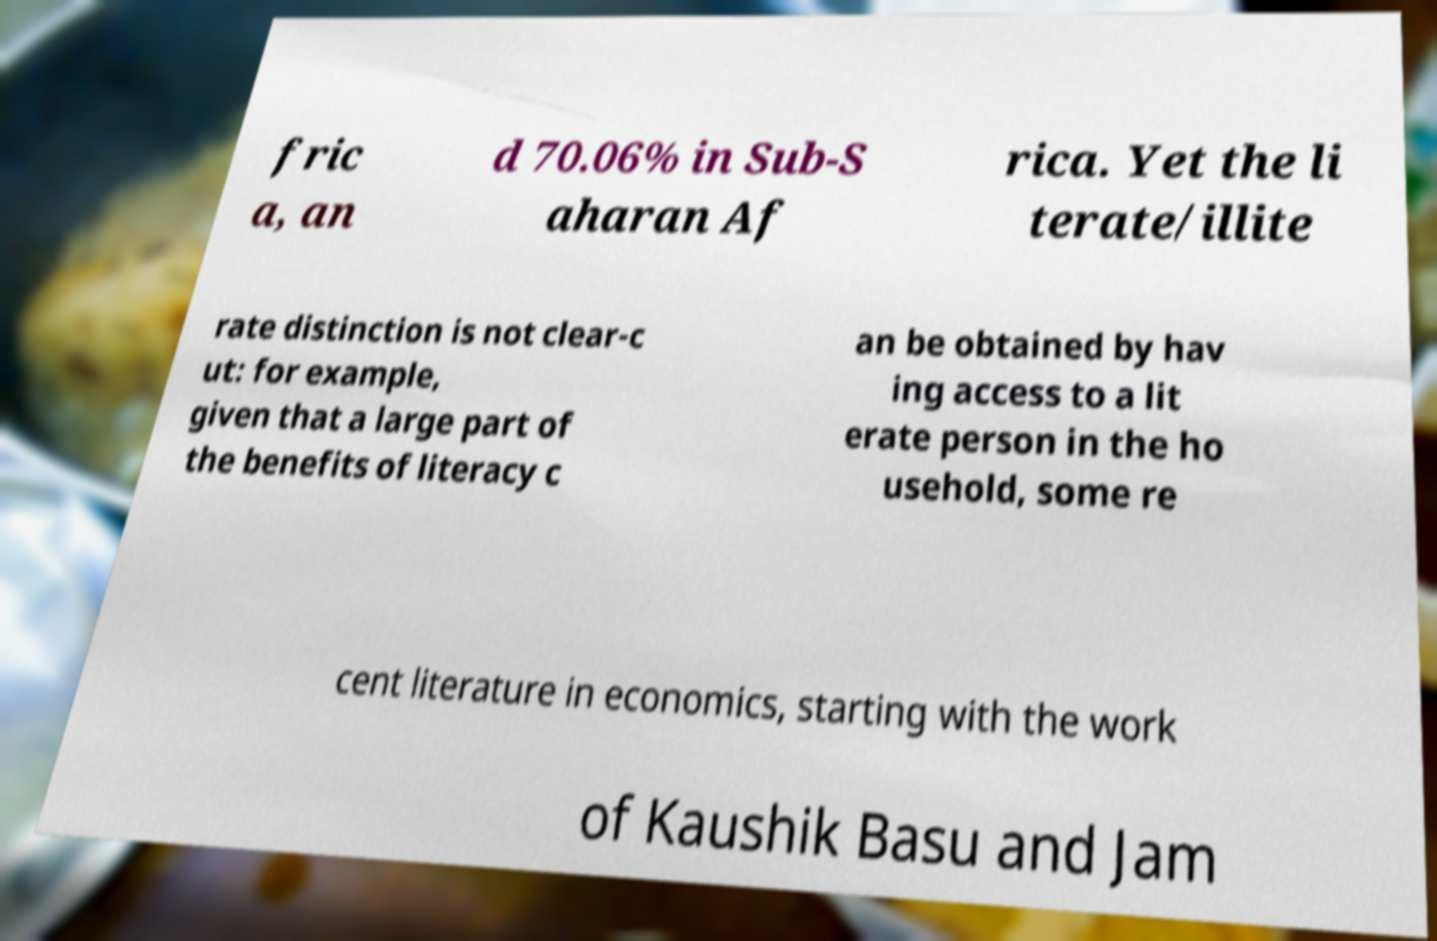Can you read and provide the text displayed in the image?This photo seems to have some interesting text. Can you extract and type it out for me? fric a, an d 70.06% in Sub-S aharan Af rica. Yet the li terate/illite rate distinction is not clear-c ut: for example, given that a large part of the benefits of literacy c an be obtained by hav ing access to a lit erate person in the ho usehold, some re cent literature in economics, starting with the work of Kaushik Basu and Jam 